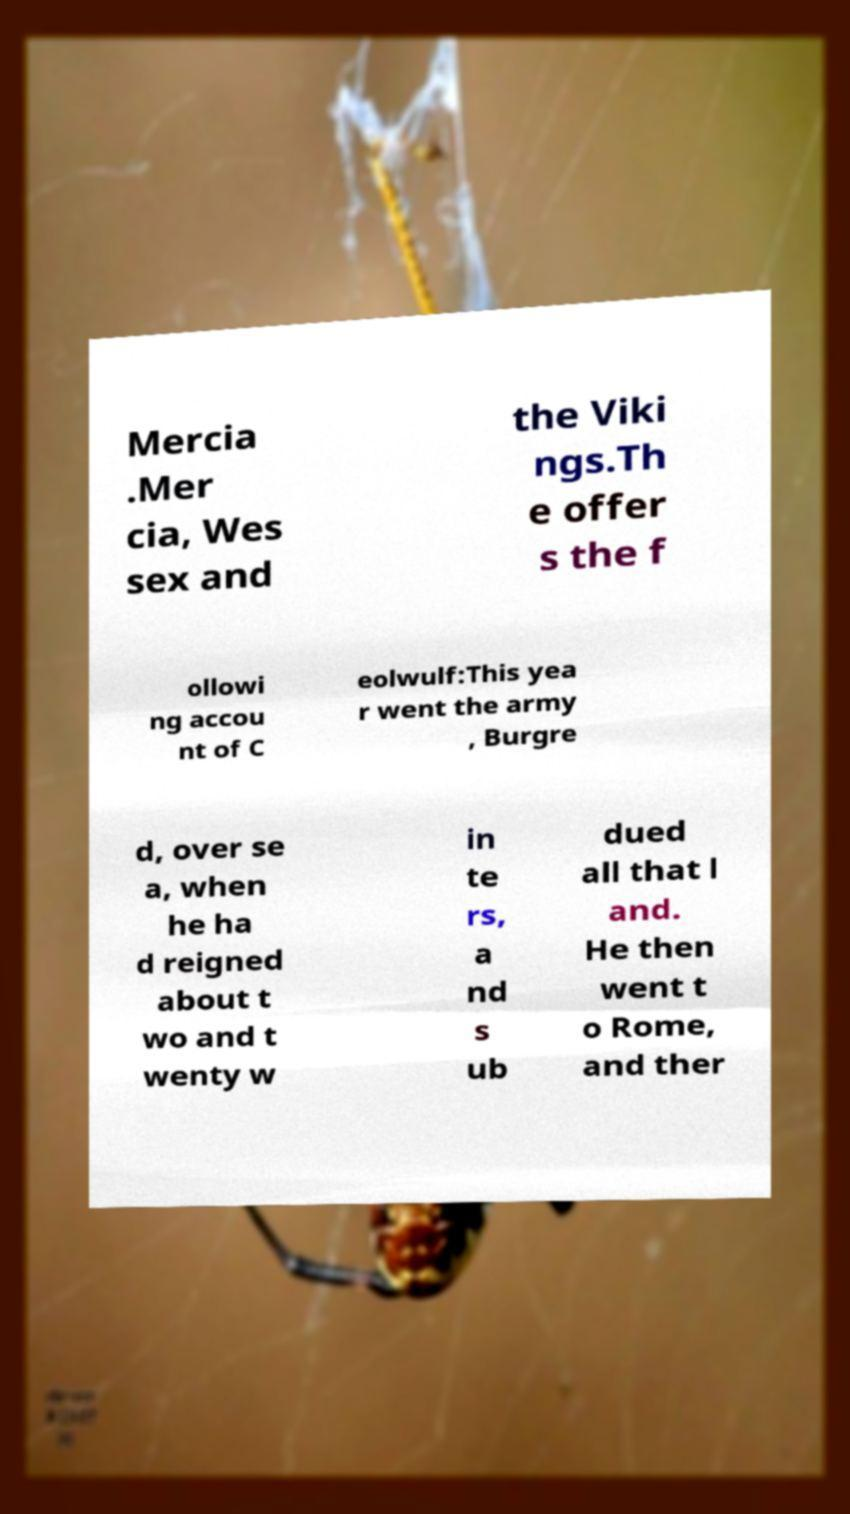Could you extract and type out the text from this image? Mercia .Mer cia, Wes sex and the Viki ngs.Th e offer s the f ollowi ng accou nt of C eolwulf:This yea r went the army , Burgre d, over se a, when he ha d reigned about t wo and t wenty w in te rs, a nd s ub dued all that l and. He then went t o Rome, and ther 